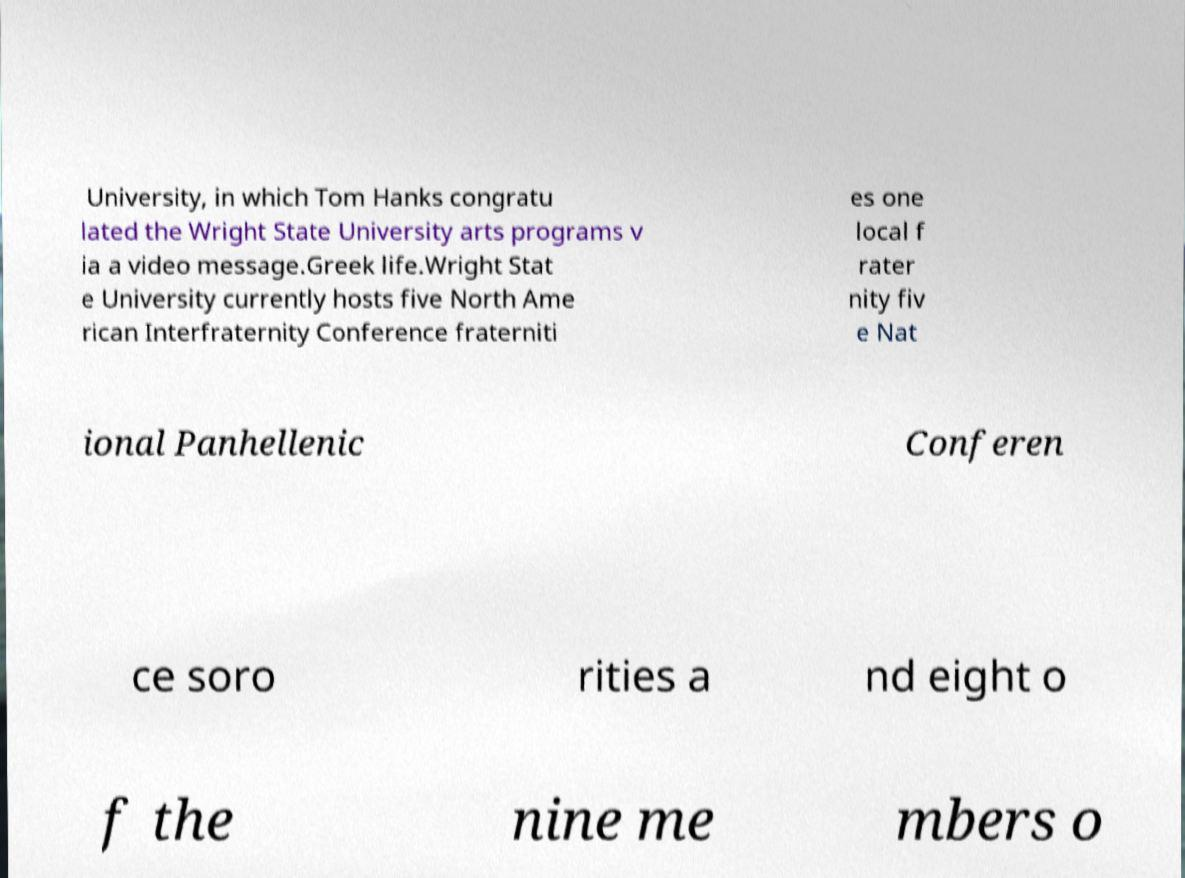Can you read and provide the text displayed in the image?This photo seems to have some interesting text. Can you extract and type it out for me? University, in which Tom Hanks congratu lated the Wright State University arts programs v ia a video message.Greek life.Wright Stat e University currently hosts five North Ame rican Interfraternity Conference fraterniti es one local f rater nity fiv e Nat ional Panhellenic Conferen ce soro rities a nd eight o f the nine me mbers o 